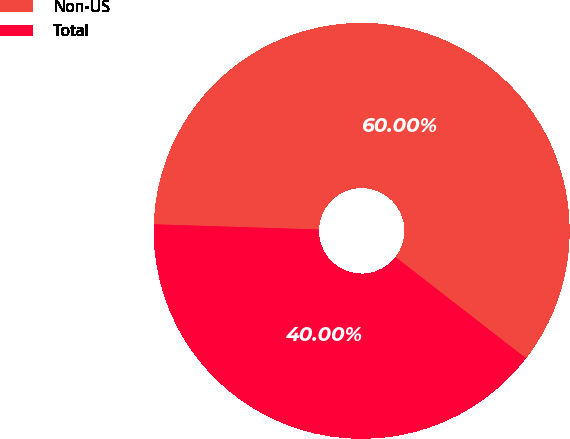Convert chart to OTSL. <chart><loc_0><loc_0><loc_500><loc_500><pie_chart><fcel>Non-US<fcel>Total<nl><fcel>60.0%<fcel>40.0%<nl></chart> 